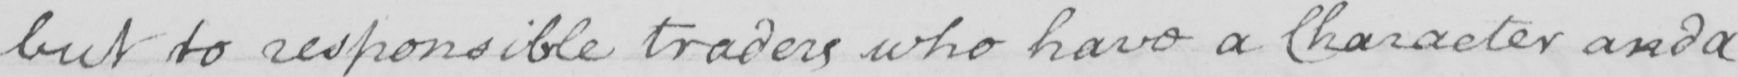What does this handwritten line say? but to responsible traders who have a Character and a 